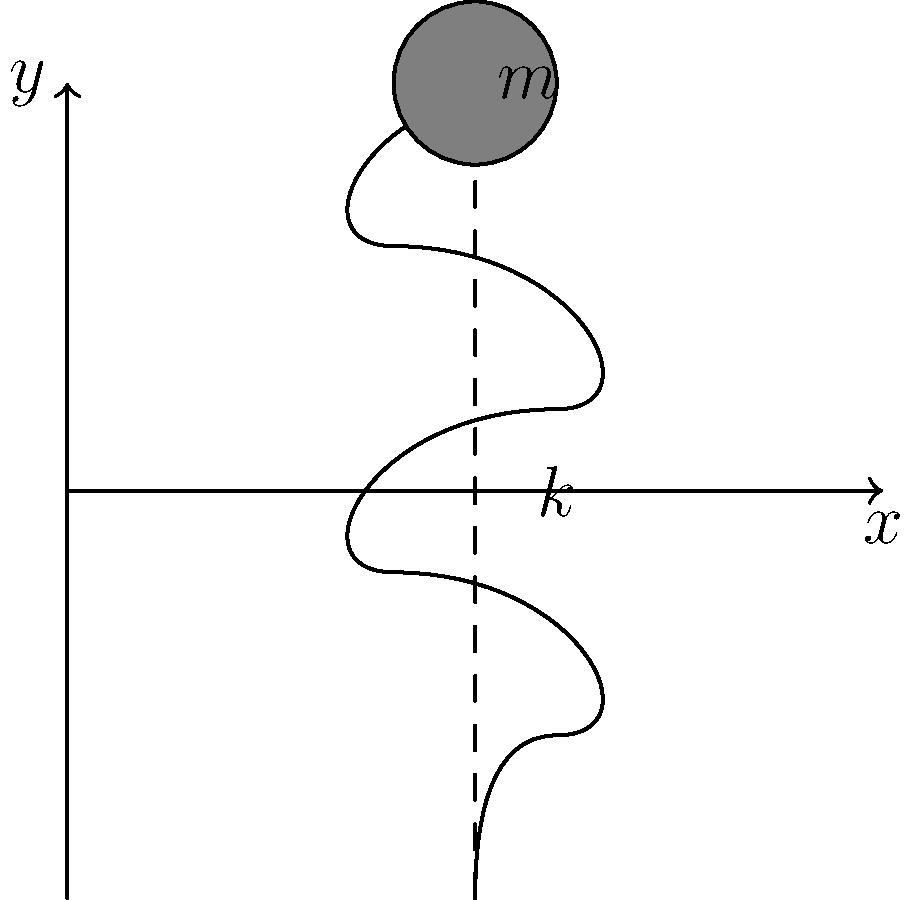As a startup founder developing a playlist algorithm, you're exploring how sound frequencies relate to physical systems. Consider a spring-mass system with a spring constant $k = 100$ N/m and a mass $m = 2$ kg. Determine the natural frequency of this system in Hz. How might understanding this concept help in developing frequency-based features for your music streaming app? To determine the natural frequency of a spring-mass system:

1) The natural frequency (in radians per second) is given by:
   $$\omega_n = \sqrt{\frac{k}{m}}$$

2) Substitute the given values:
   $$\omega_n = \sqrt{\frac{100 \text{ N/m}}{2 \text{ kg}}}$$

3) Calculate:
   $$\omega_n = \sqrt{50} \approx 7.071 \text{ rad/s}$$

4) Convert from radians per second to Hz:
   $$f_n = \frac{\omega_n}{2\pi} = \frac{7.071}{2\pi} \approx 1.125 \text{ Hz}$$

Understanding natural frequencies can help in developing features like:
- Categorizing songs based on their dominant frequencies
- Creating smooth transitions between songs with similar frequency profiles
- Implementing audio equalizer presets based on frequency ranges
Answer: 1.125 Hz 